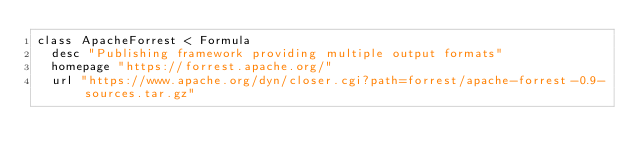Convert code to text. <code><loc_0><loc_0><loc_500><loc_500><_Ruby_>class ApacheForrest < Formula
  desc "Publishing framework providing multiple output formats"
  homepage "https://forrest.apache.org/"
  url "https://www.apache.org/dyn/closer.cgi?path=forrest/apache-forrest-0.9-sources.tar.gz"</code> 